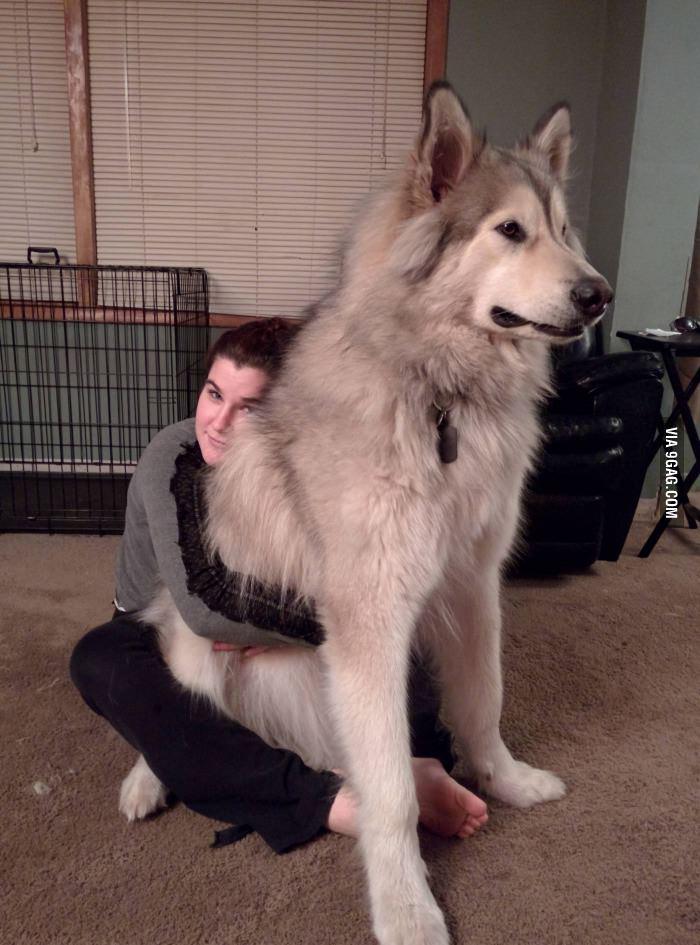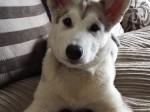The first image is the image on the left, the second image is the image on the right. Assess this claim about the two images: "There is at least one human in the image pair.". Correct or not? Answer yes or no. Yes. The first image is the image on the left, the second image is the image on the right. Analyze the images presented: Is the assertion "The left image features one dog, which is facing rightward, and the right image features a reclining dog with its head upright and body facing forward." valid? Answer yes or no. Yes. 